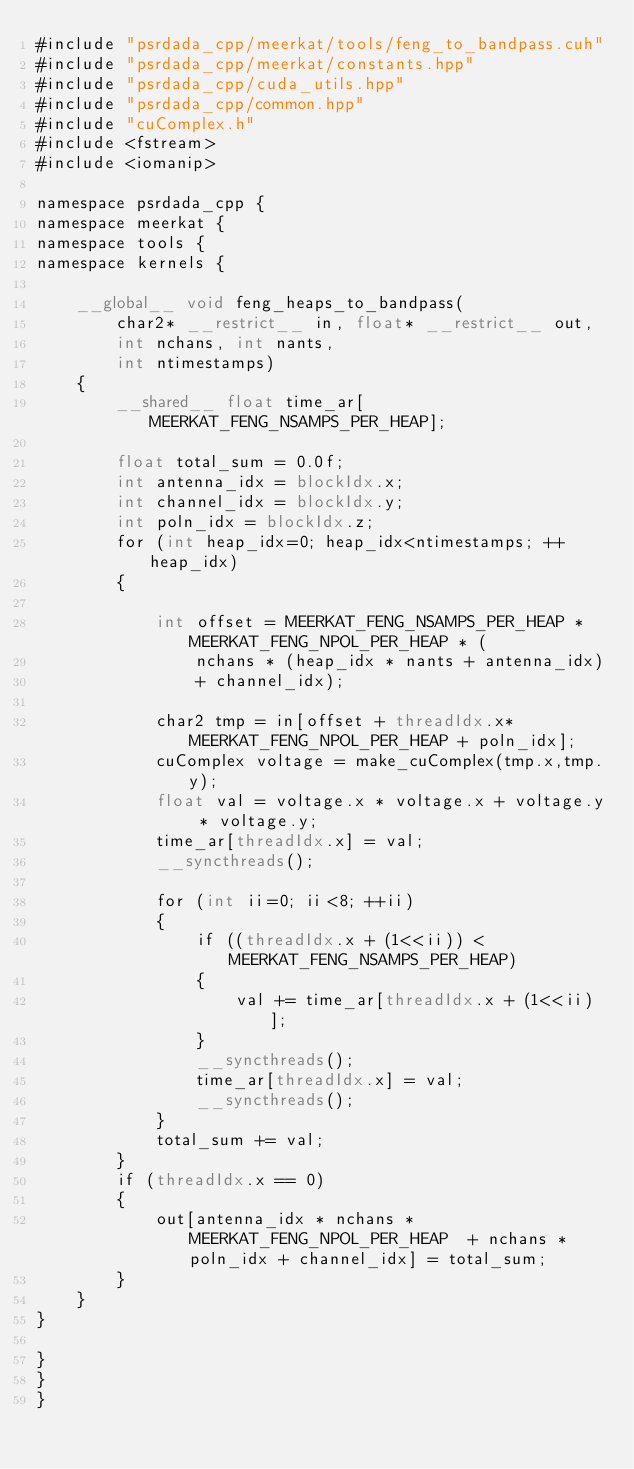Convert code to text. <code><loc_0><loc_0><loc_500><loc_500><_Cuda_>#include "psrdada_cpp/meerkat/tools/feng_to_bandpass.cuh"
#include "psrdada_cpp/meerkat/constants.hpp"
#include "psrdada_cpp/cuda_utils.hpp"
#include "psrdada_cpp/common.hpp"
#include "cuComplex.h"
#include <fstream>
#include <iomanip>

namespace psrdada_cpp {
namespace meerkat {
namespace tools {
namespace kernels {

    __global__ void feng_heaps_to_bandpass(
        char2* __restrict__ in, float* __restrict__ out,
        int nchans, int nants,
        int ntimestamps)
    {
        __shared__ float time_ar[MEERKAT_FENG_NSAMPS_PER_HEAP];

        float total_sum = 0.0f;
        int antenna_idx = blockIdx.x;
        int channel_idx = blockIdx.y;
        int poln_idx = blockIdx.z;
        for (int heap_idx=0; heap_idx<ntimestamps; ++heap_idx)
        {

            int offset = MEERKAT_FENG_NSAMPS_PER_HEAP * MEERKAT_FENG_NPOL_PER_HEAP * (
                nchans * (heap_idx * nants + antenna_idx)
                + channel_idx);

            char2 tmp = in[offset + threadIdx.x*MEERKAT_FENG_NPOL_PER_HEAP + poln_idx];
            cuComplex voltage = make_cuComplex(tmp.x,tmp.y);
            float val = voltage.x * voltage.x + voltage.y * voltage.y;
            time_ar[threadIdx.x] = val;
            __syncthreads();

            for (int ii=0; ii<8; ++ii)
            {
                if ((threadIdx.x + (1<<ii)) < MEERKAT_FENG_NSAMPS_PER_HEAP)
                {
                    val += time_ar[threadIdx.x + (1<<ii)];
                }
                __syncthreads();
                time_ar[threadIdx.x] = val;
                __syncthreads();
            }
            total_sum += val;
        }
        if (threadIdx.x == 0)
        {
            out[antenna_idx * nchans * MEERKAT_FENG_NPOL_PER_HEAP  + nchans * poln_idx + channel_idx] = total_sum;
        }
    }
}

}
}
}</code> 